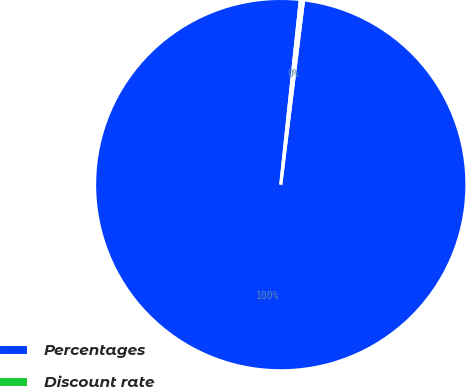<chart> <loc_0><loc_0><loc_500><loc_500><pie_chart><fcel>Percentages<fcel>Discount rate<nl><fcel>99.72%<fcel>0.28%<nl></chart> 